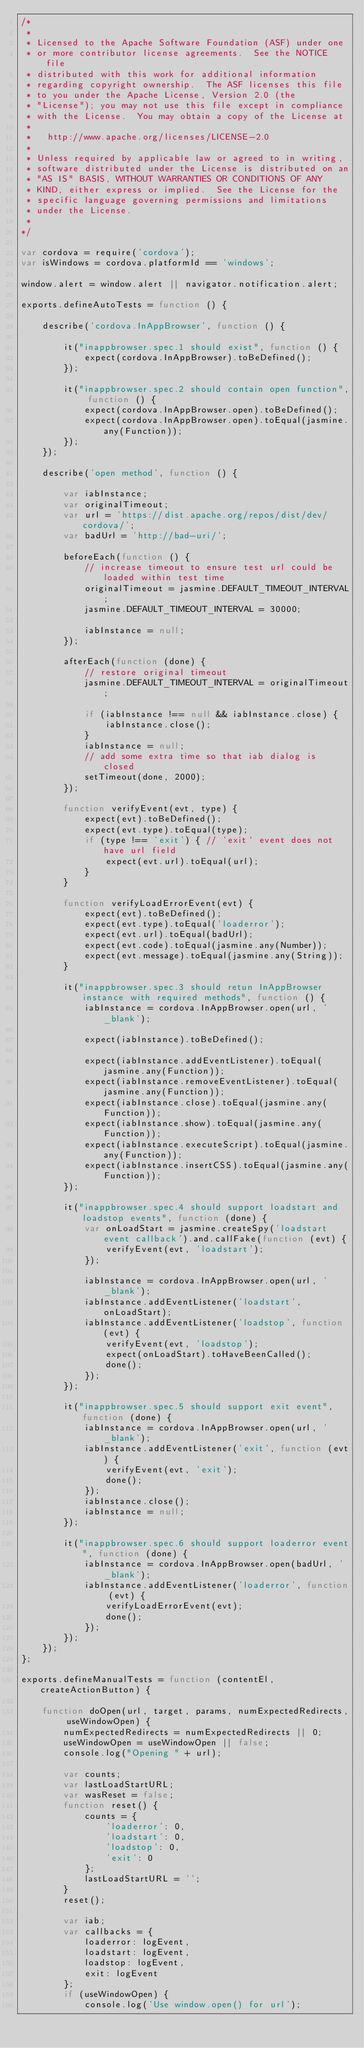<code> <loc_0><loc_0><loc_500><loc_500><_JavaScript_>/*
 *
 * Licensed to the Apache Software Foundation (ASF) under one
 * or more contributor license agreements.  See the NOTICE file
 * distributed with this work for additional information
 * regarding copyright ownership.  The ASF licenses this file
 * to you under the Apache License, Version 2.0 (the
 * "License"); you may not use this file except in compliance
 * with the License.  You may obtain a copy of the License at
 *
 *   http://www.apache.org/licenses/LICENSE-2.0
 *
 * Unless required by applicable law or agreed to in writing,
 * software distributed under the License is distributed on an
 * "AS IS" BASIS, WITHOUT WARRANTIES OR CONDITIONS OF ANY
 * KIND, either express or implied.  See the License for the
 * specific language governing permissions and limitations
 * under the License.
 *
*/

var cordova = require('cordova');
var isWindows = cordova.platformId == 'windows';

window.alert = window.alert || navigator.notification.alert;

exports.defineAutoTests = function () {

    describe('cordova.InAppBrowser', function () {

        it("inappbrowser.spec.1 should exist", function () {
            expect(cordova.InAppBrowser).toBeDefined();
        });

        it("inappbrowser.spec.2 should contain open function", function () {
            expect(cordova.InAppBrowser.open).toBeDefined();
            expect(cordova.InAppBrowser.open).toEqual(jasmine.any(Function));
        });
    });

    describe('open method', function () {

        var iabInstance;
        var originalTimeout;
        var url = 'https://dist.apache.org/repos/dist/dev/cordova/';
        var badUrl = 'http://bad-uri/';

        beforeEach(function () {
            // increase timeout to ensure test url could be loaded within test time
            originalTimeout = jasmine.DEFAULT_TIMEOUT_INTERVAL;
            jasmine.DEFAULT_TIMEOUT_INTERVAL = 30000;

            iabInstance = null;
        });

        afterEach(function (done) {
            // restore original timeout
            jasmine.DEFAULT_TIMEOUT_INTERVAL = originalTimeout;

            if (iabInstance !== null && iabInstance.close) {
                iabInstance.close();
            }
            iabInstance = null;
            // add some extra time so that iab dialog is closed
            setTimeout(done, 2000);
        });

        function verifyEvent(evt, type) {
            expect(evt).toBeDefined();
            expect(evt.type).toEqual(type);
            if (type !== 'exit') { // `exit` event does not have url field
                expect(evt.url).toEqual(url);
            }
        }

        function verifyLoadErrorEvent(evt) {
            expect(evt).toBeDefined();
            expect(evt.type).toEqual('loaderror');
            expect(evt.url).toEqual(badUrl);
            expect(evt.code).toEqual(jasmine.any(Number));
            expect(evt.message).toEqual(jasmine.any(String));
        }

        it("inappbrowser.spec.3 should retun InAppBrowser instance with required methods", function () {
            iabInstance = cordova.InAppBrowser.open(url, '_blank');

            expect(iabInstance).toBeDefined();

            expect(iabInstance.addEventListener).toEqual(jasmine.any(Function));
            expect(iabInstance.removeEventListener).toEqual(jasmine.any(Function));
            expect(iabInstance.close).toEqual(jasmine.any(Function));
            expect(iabInstance.show).toEqual(jasmine.any(Function));
            expect(iabInstance.executeScript).toEqual(jasmine.any(Function));
            expect(iabInstance.insertCSS).toEqual(jasmine.any(Function));
        });

        it("inappbrowser.spec.4 should support loadstart and loadstop events", function (done) {
            var onLoadStart = jasmine.createSpy('loadstart event callback').and.callFake(function (evt) {
                verifyEvent(evt, 'loadstart');
            });

            iabInstance = cordova.InAppBrowser.open(url, '_blank');
            iabInstance.addEventListener('loadstart', onLoadStart);
            iabInstance.addEventListener('loadstop', function (evt) {
                verifyEvent(evt, 'loadstop');
                expect(onLoadStart).toHaveBeenCalled();
                done();
            });
        });

        it("inappbrowser.spec.5 should support exit event", function (done) {
            iabInstance = cordova.InAppBrowser.open(url, '_blank');
            iabInstance.addEventListener('exit', function (evt) {
                verifyEvent(evt, 'exit');
                done();
            });
            iabInstance.close();
            iabInstance = null;
        });

        it("inappbrowser.spec.6 should support loaderror event", function (done) {
            iabInstance = cordova.InAppBrowser.open(badUrl, '_blank');
            iabInstance.addEventListener('loaderror', function (evt) {
                verifyLoadErrorEvent(evt);
                done();
            });
        });
    });
};

exports.defineManualTests = function (contentEl, createActionButton) {

    function doOpen(url, target, params, numExpectedRedirects, useWindowOpen) {
        numExpectedRedirects = numExpectedRedirects || 0;
        useWindowOpen = useWindowOpen || false;
        console.log("Opening " + url);

        var counts;
        var lastLoadStartURL;
        var wasReset = false;
        function reset() {
            counts = {
                'loaderror': 0,
                'loadstart': 0,
                'loadstop': 0,
                'exit': 0
            };
            lastLoadStartURL = '';
        }
        reset();

        var iab;
        var callbacks = {
            loaderror: logEvent,
            loadstart: logEvent,
            loadstop: logEvent,
            exit: logEvent
        };
        if (useWindowOpen) {
            console.log('Use window.open() for url');</code> 